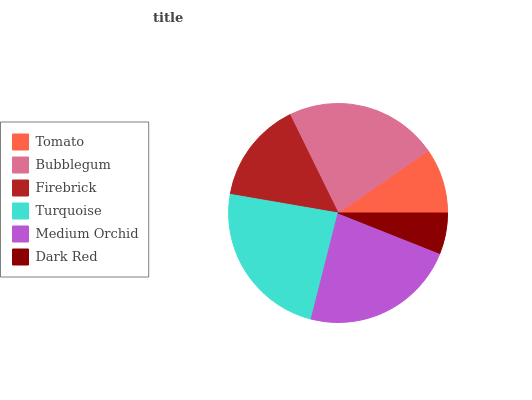Is Dark Red the minimum?
Answer yes or no. Yes. Is Turquoise the maximum?
Answer yes or no. Yes. Is Bubblegum the minimum?
Answer yes or no. No. Is Bubblegum the maximum?
Answer yes or no. No. Is Bubblegum greater than Tomato?
Answer yes or no. Yes. Is Tomato less than Bubblegum?
Answer yes or no. Yes. Is Tomato greater than Bubblegum?
Answer yes or no. No. Is Bubblegum less than Tomato?
Answer yes or no. No. Is Bubblegum the high median?
Answer yes or no. Yes. Is Firebrick the low median?
Answer yes or no. Yes. Is Dark Red the high median?
Answer yes or no. No. Is Bubblegum the low median?
Answer yes or no. No. 